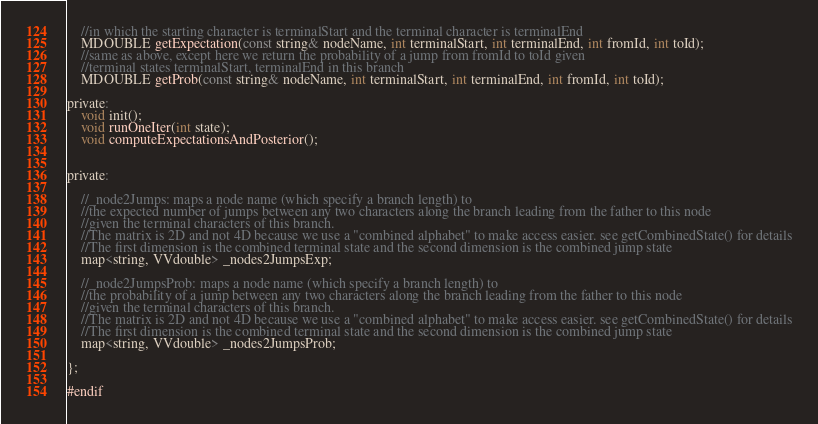Convert code to text. <code><loc_0><loc_0><loc_500><loc_500><_C_>	//in which the starting character is terminalStart and the terminal character is terminalEnd
	MDOUBLE getExpectation(const string& nodeName, int terminalStart, int terminalEnd, int fromId, int toId);
	//same as above, except here we return the probability of a jump from fromId to toId given 
	//terminal states terminalStart, terminalEnd in this branch
	MDOUBLE getProb(const string& nodeName, int terminalStart, int terminalEnd, int fromId, int toId);
    	
private:
	void init();
	void runOneIter(int state);
	void computeExpectationsAndPosterior();
	

private:

	//_node2Jumps: maps a node name (which specify a branch length) to 
	//the expected number of jumps between any two characters along the branch leading from the father to this node
	//given the terminal characters of this branch.
	//The matrix is 2D and not 4D because we use a "combined alphabet" to make access easier. see getCombinedState() for details
	//The first dimension is the combined terminal state and the second dimension is the combined jump state
	map<string, VVdouble> _nodes2JumpsExp; 
	
	//_node2JumpsProb: maps a node name (which specify a branch length) to 
	//the probability of a jump between any two characters along the branch leading from the father to this node
	//given the terminal characters of this branch.
	//The matrix is 2D and not 4D because we use a "combined alphabet" to make access easier. see getCombinedState() for details
	//The first dimension is the combined terminal state and the second dimension is the combined jump state
	map<string, VVdouble> _nodes2JumpsProb; 

};

#endif
</code> 